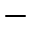<formula> <loc_0><loc_0><loc_500><loc_500>-</formula> 